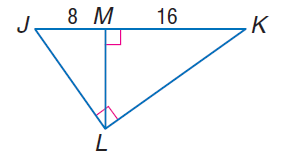Question: Find the measure of the altitude drawn to the hypotenuse.
Choices:
A. 8
B. 8 \sqrt { 2 }
C. 16
D. 16 \sqrt { 2 }
Answer with the letter. Answer: B 